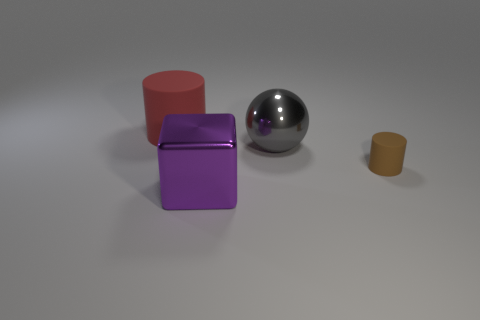Subtract all spheres. How many objects are left? 3 Add 4 brown matte blocks. How many objects exist? 8 Subtract all gray blocks. Subtract all green balls. How many blocks are left? 1 Subtract all yellow balls. How many red cylinders are left? 1 Subtract all large gray things. Subtract all gray things. How many objects are left? 2 Add 4 big gray metallic things. How many big gray metallic things are left? 5 Add 3 metal spheres. How many metal spheres exist? 4 Subtract 0 purple balls. How many objects are left? 4 